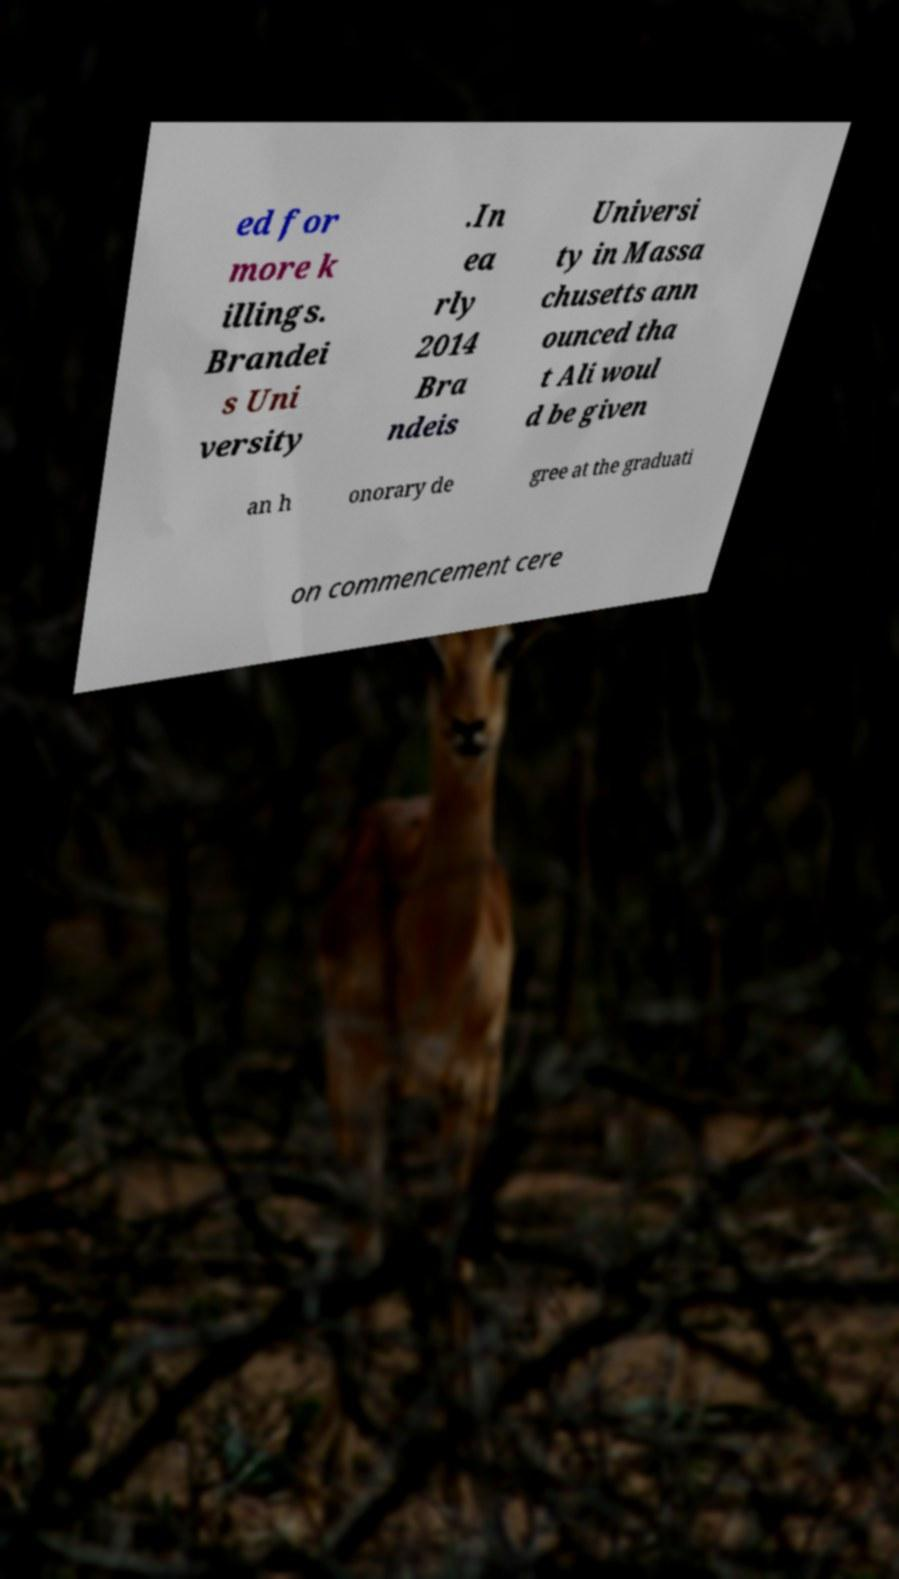Please identify and transcribe the text found in this image. ed for more k illings. Brandei s Uni versity .In ea rly 2014 Bra ndeis Universi ty in Massa chusetts ann ounced tha t Ali woul d be given an h onorary de gree at the graduati on commencement cere 